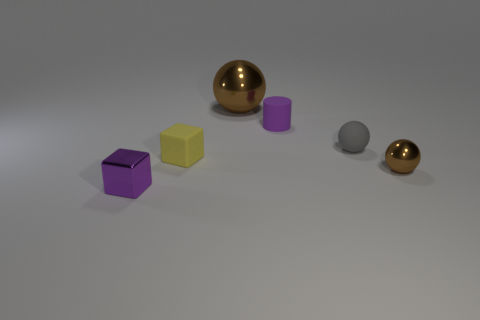How many other things are there of the same color as the tiny metal block?
Keep it short and to the point. 1. How many brown objects are either rubber cubes or large balls?
Provide a succinct answer. 1. What size is the matte block?
Your response must be concise. Small. What number of rubber objects are yellow objects or cyan objects?
Ensure brevity in your answer.  1. Is the number of big metal blocks less than the number of small yellow cubes?
Your response must be concise. Yes. What number of other objects are the same material as the yellow cube?
Make the answer very short. 2. The purple object that is the same shape as the yellow matte thing is what size?
Offer a very short reply. Small. Do the small sphere that is in front of the gray thing and the purple thing that is to the left of the big thing have the same material?
Make the answer very short. Yes. Is the number of spheres that are on the left side of the tiny purple block less than the number of small purple cubes?
Ensure brevity in your answer.  Yes. Is there anything else that is the same shape as the big metallic thing?
Offer a terse response. Yes. 